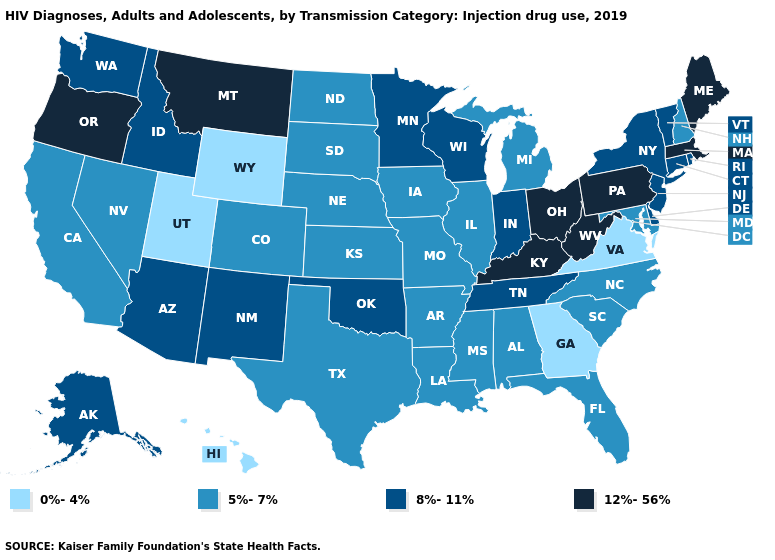Which states have the lowest value in the South?
Keep it brief. Georgia, Virginia. Name the states that have a value in the range 8%-11%?
Quick response, please. Alaska, Arizona, Connecticut, Delaware, Idaho, Indiana, Minnesota, New Jersey, New Mexico, New York, Oklahoma, Rhode Island, Tennessee, Vermont, Washington, Wisconsin. Among the states that border Iowa , which have the highest value?
Be succinct. Minnesota, Wisconsin. Does the map have missing data?
Keep it brief. No. Among the states that border Vermont , which have the lowest value?
Short answer required. New Hampshire. Name the states that have a value in the range 5%-7%?
Give a very brief answer. Alabama, Arkansas, California, Colorado, Florida, Illinois, Iowa, Kansas, Louisiana, Maryland, Michigan, Mississippi, Missouri, Nebraska, Nevada, New Hampshire, North Carolina, North Dakota, South Carolina, South Dakota, Texas. What is the lowest value in the USA?
Concise answer only. 0%-4%. What is the value of Rhode Island?
Short answer required. 8%-11%. What is the lowest value in the USA?
Short answer required. 0%-4%. Does Tennessee have a lower value than Indiana?
Short answer required. No. Does Indiana have the highest value in the MidWest?
Concise answer only. No. What is the lowest value in the South?
Write a very short answer. 0%-4%. Name the states that have a value in the range 5%-7%?
Give a very brief answer. Alabama, Arkansas, California, Colorado, Florida, Illinois, Iowa, Kansas, Louisiana, Maryland, Michigan, Mississippi, Missouri, Nebraska, Nevada, New Hampshire, North Carolina, North Dakota, South Carolina, South Dakota, Texas. Does the map have missing data?
Write a very short answer. No. Is the legend a continuous bar?
Keep it brief. No. 